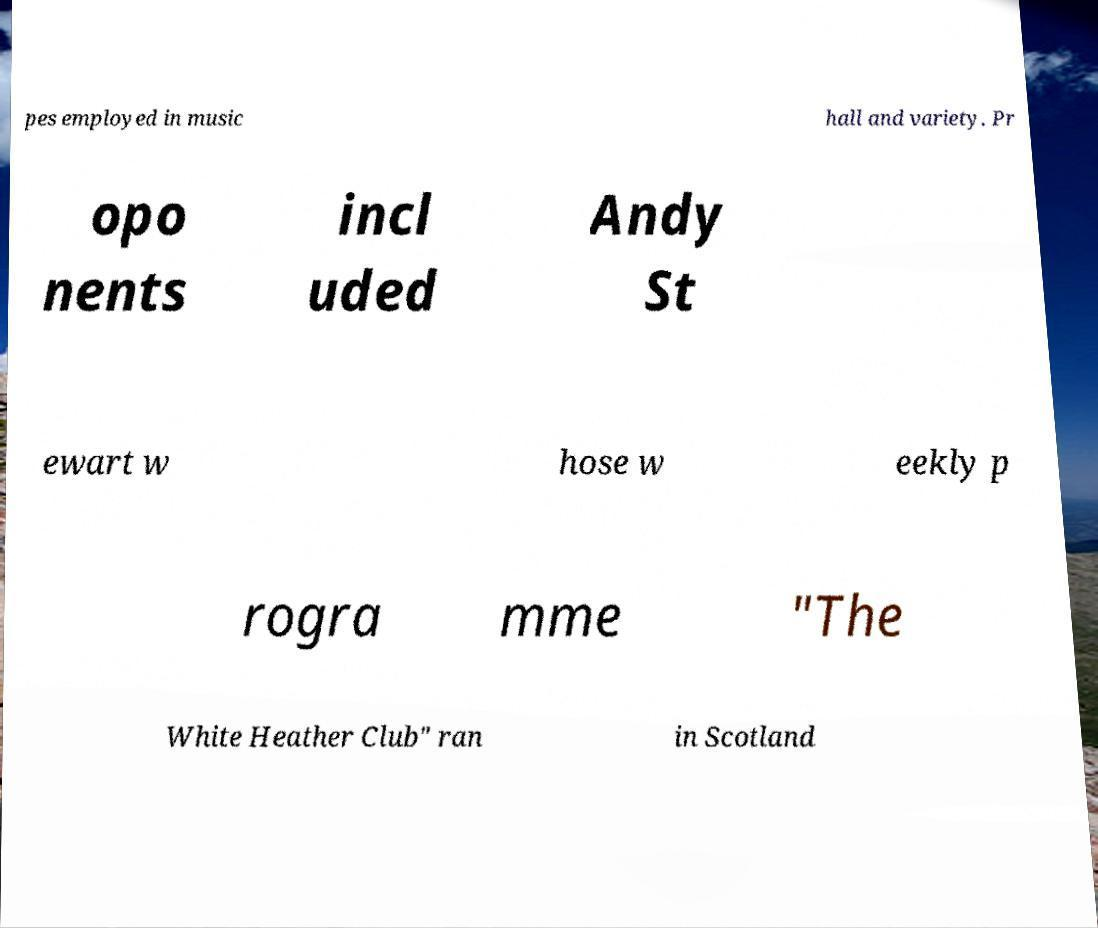Please read and relay the text visible in this image. What does it say? pes employed in music hall and variety. Pr opo nents incl uded Andy St ewart w hose w eekly p rogra mme "The White Heather Club" ran in Scotland 